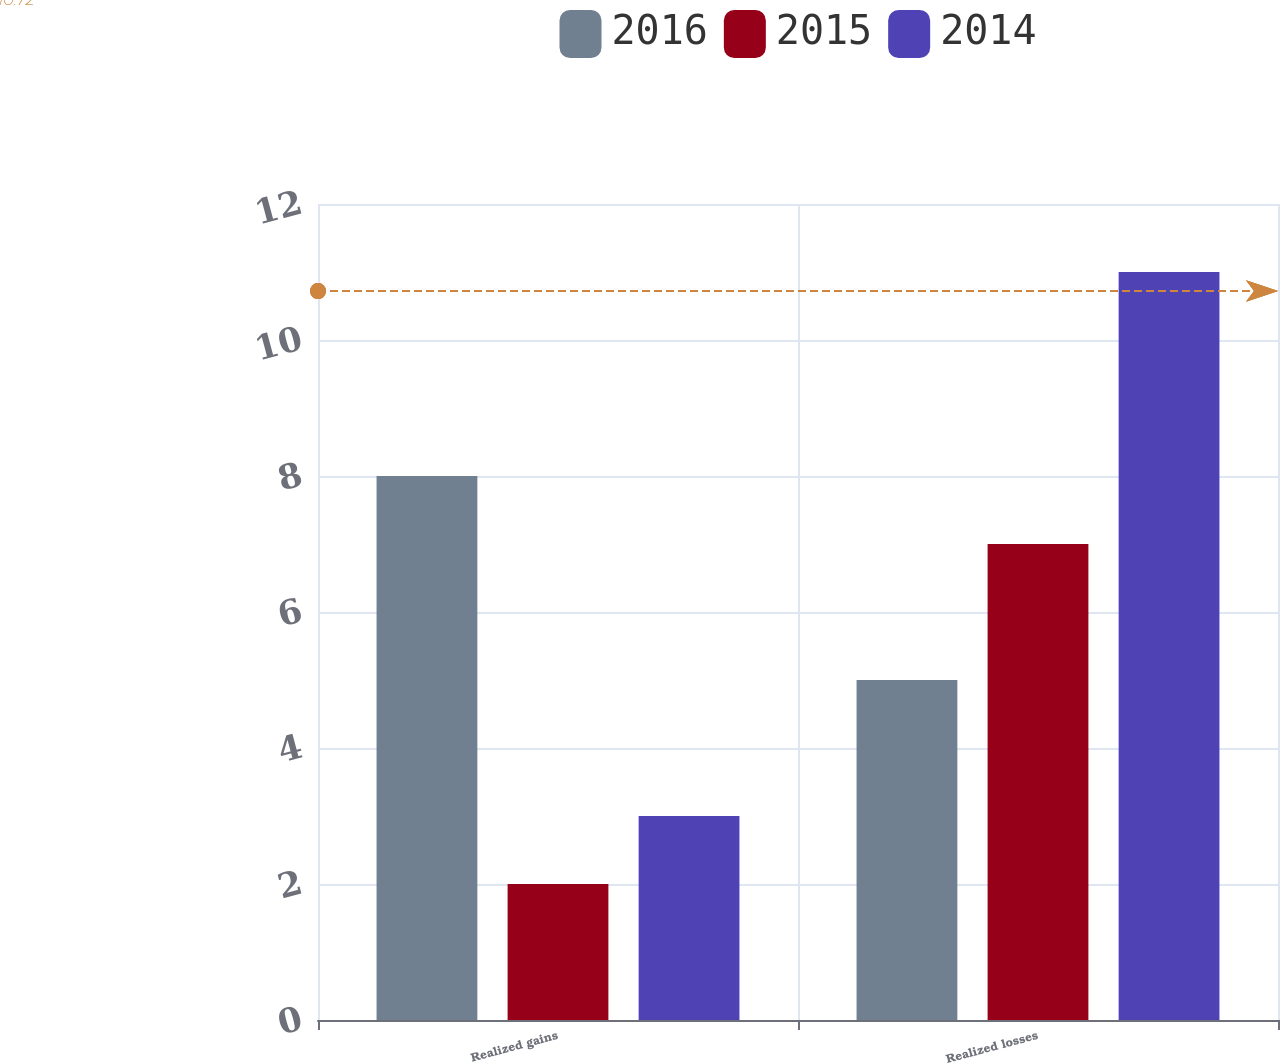Convert chart to OTSL. <chart><loc_0><loc_0><loc_500><loc_500><stacked_bar_chart><ecel><fcel>Realized gains<fcel>Realized losses<nl><fcel>2016<fcel>8<fcel>5<nl><fcel>2015<fcel>2<fcel>7<nl><fcel>2014<fcel>3<fcel>11<nl></chart> 